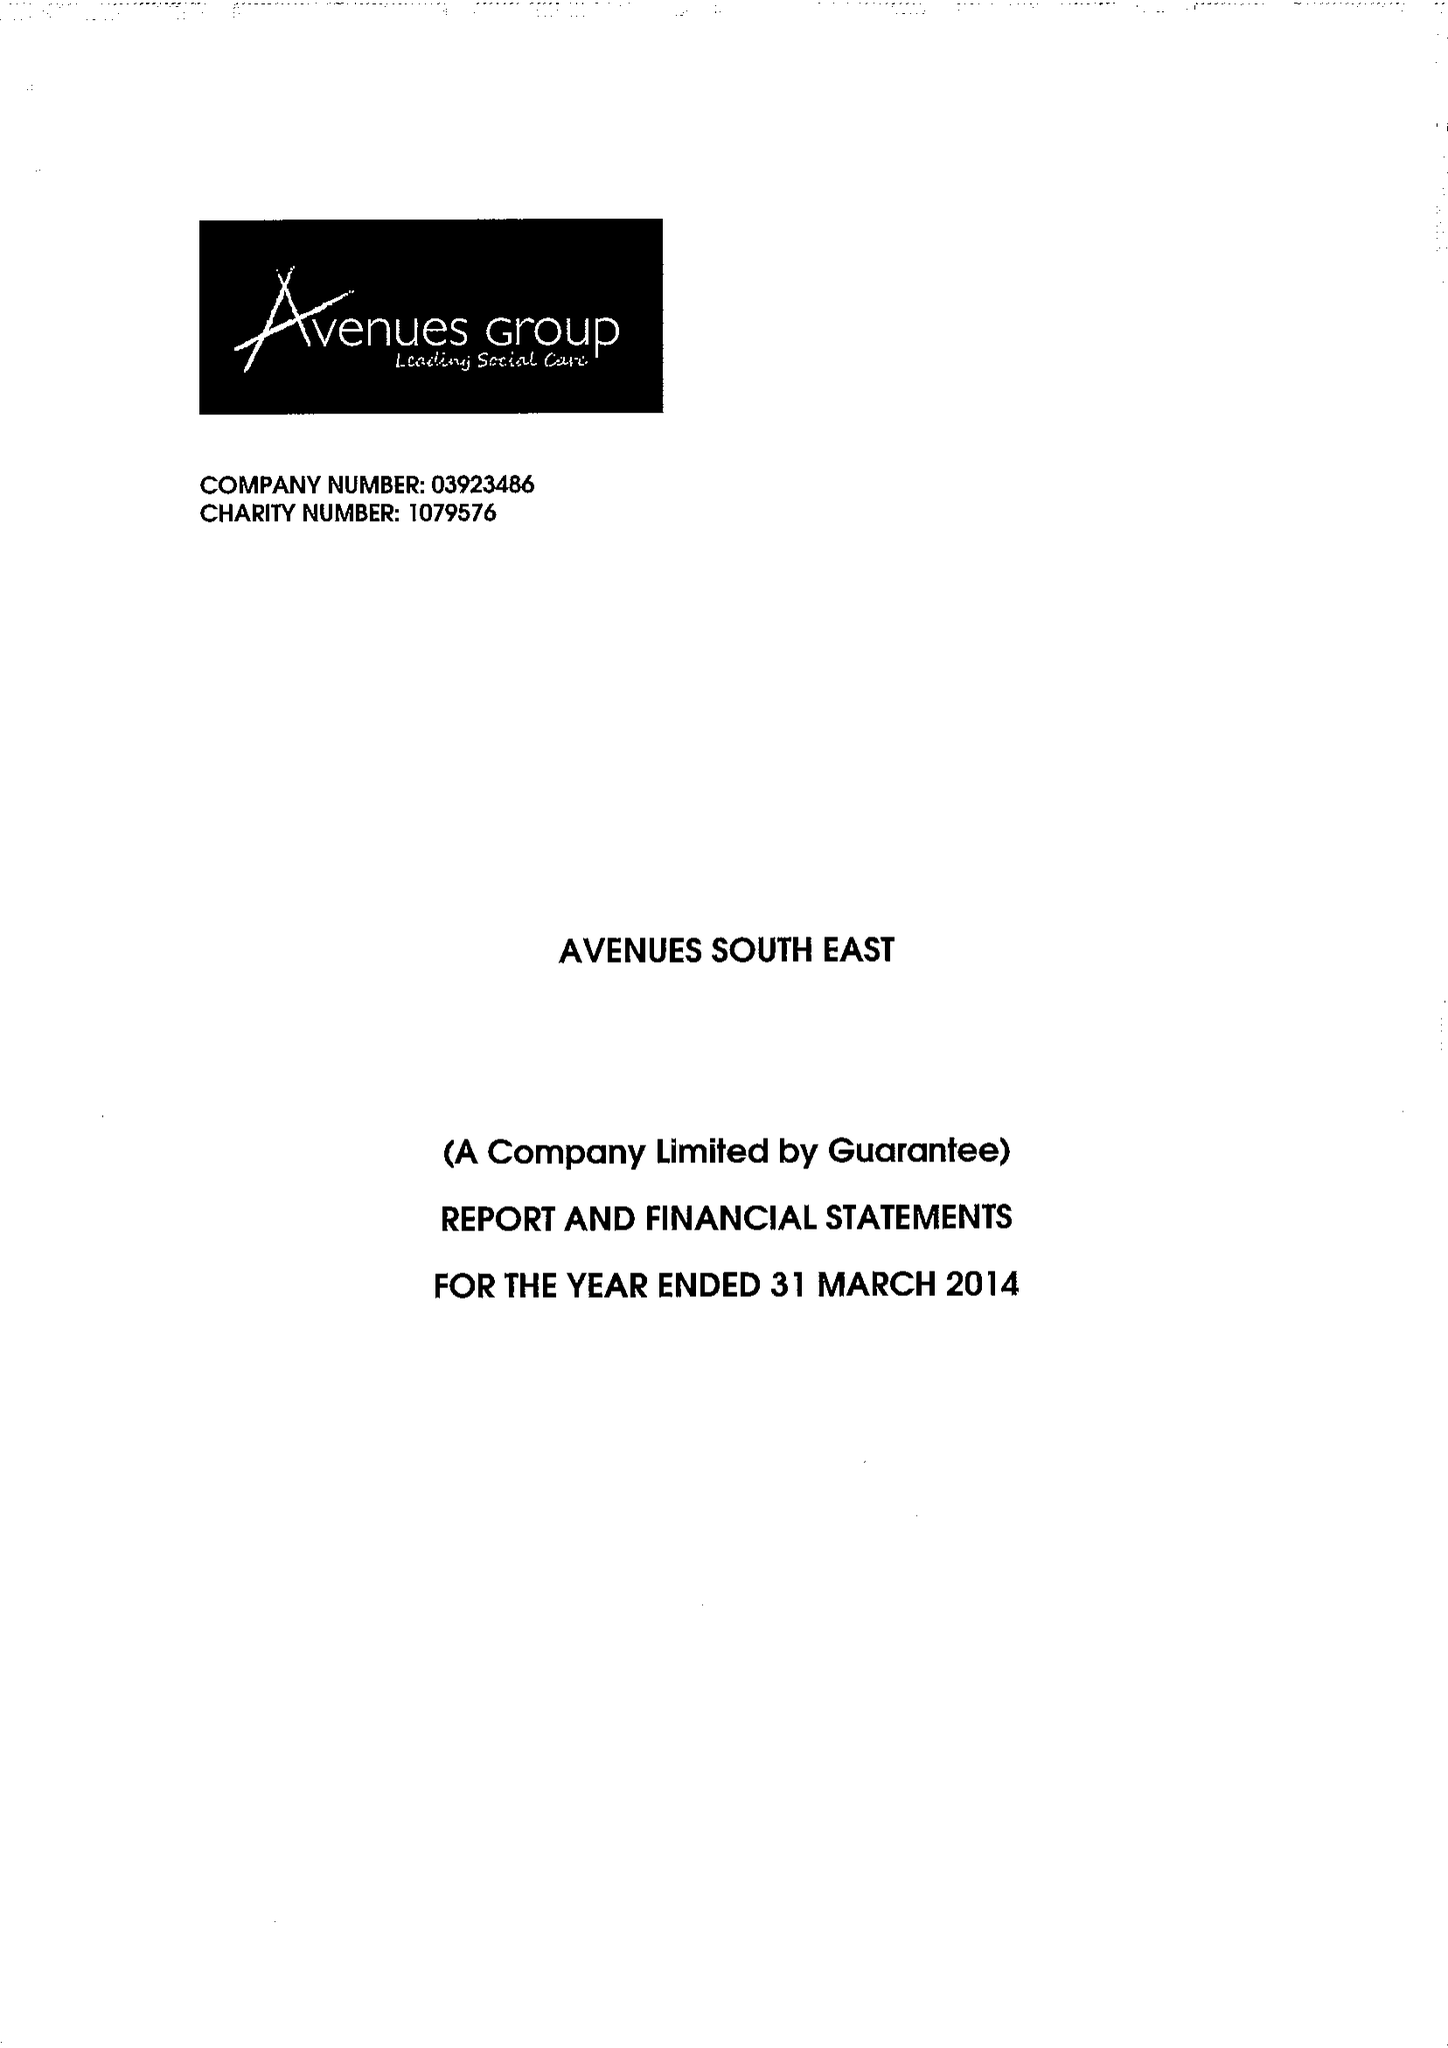What is the value for the income_annually_in_british_pounds?
Answer the question using a single word or phrase. 14022637.00 